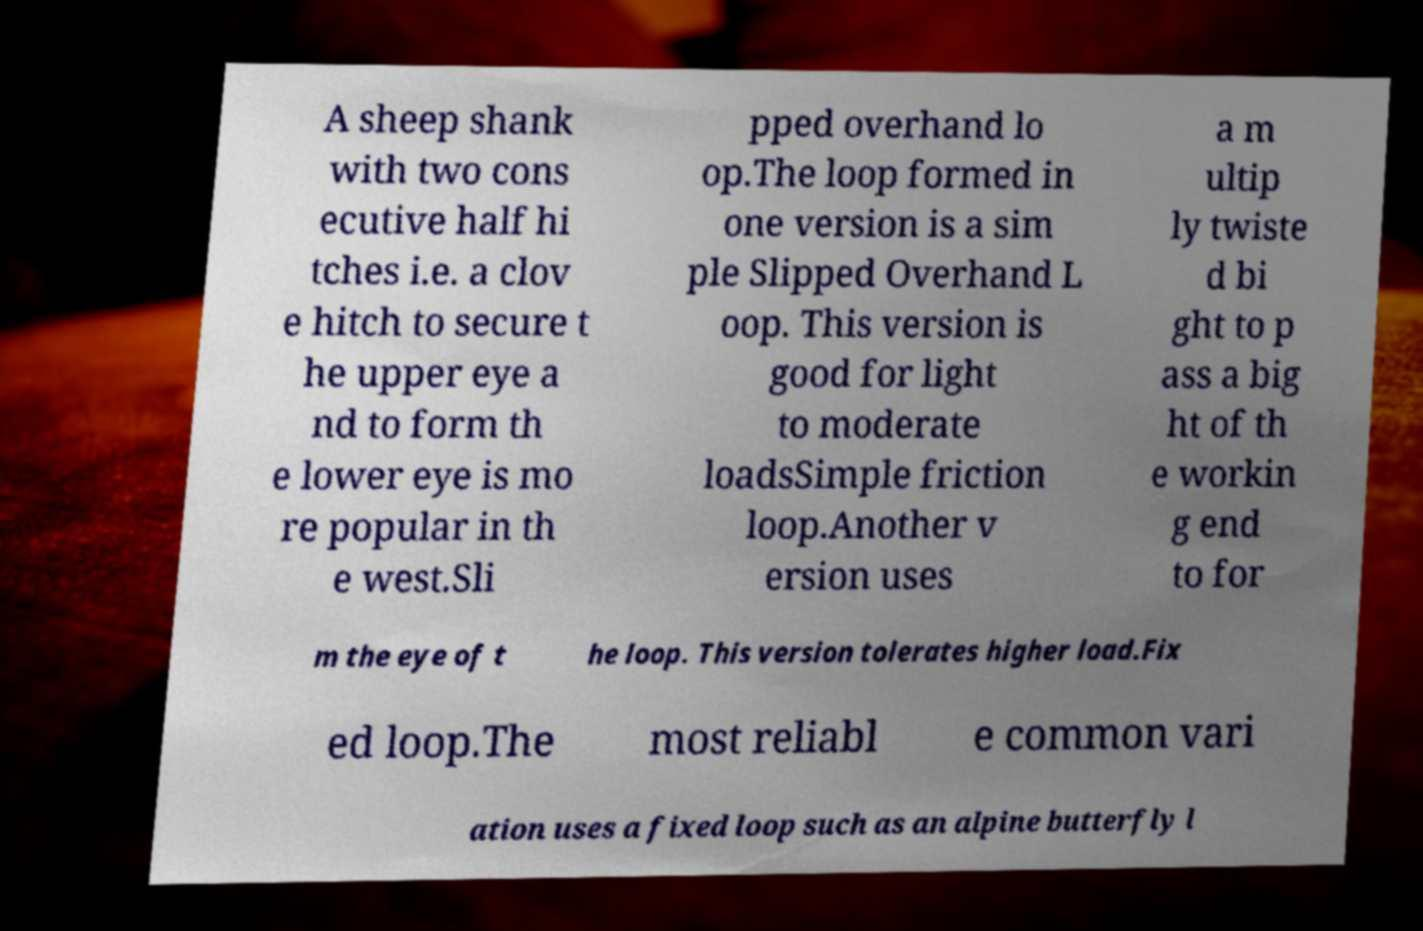There's text embedded in this image that I need extracted. Can you transcribe it verbatim? A sheep shank with two cons ecutive half hi tches i.e. a clov e hitch to secure t he upper eye a nd to form th e lower eye is mo re popular in th e west.Sli pped overhand lo op.The loop formed in one version is a sim ple Slipped Overhand L oop. This version is good for light to moderate loadsSimple friction loop.Another v ersion uses a m ultip ly twiste d bi ght to p ass a big ht of th e workin g end to for m the eye of t he loop. This version tolerates higher load.Fix ed loop.The most reliabl e common vari ation uses a fixed loop such as an alpine butterfly l 